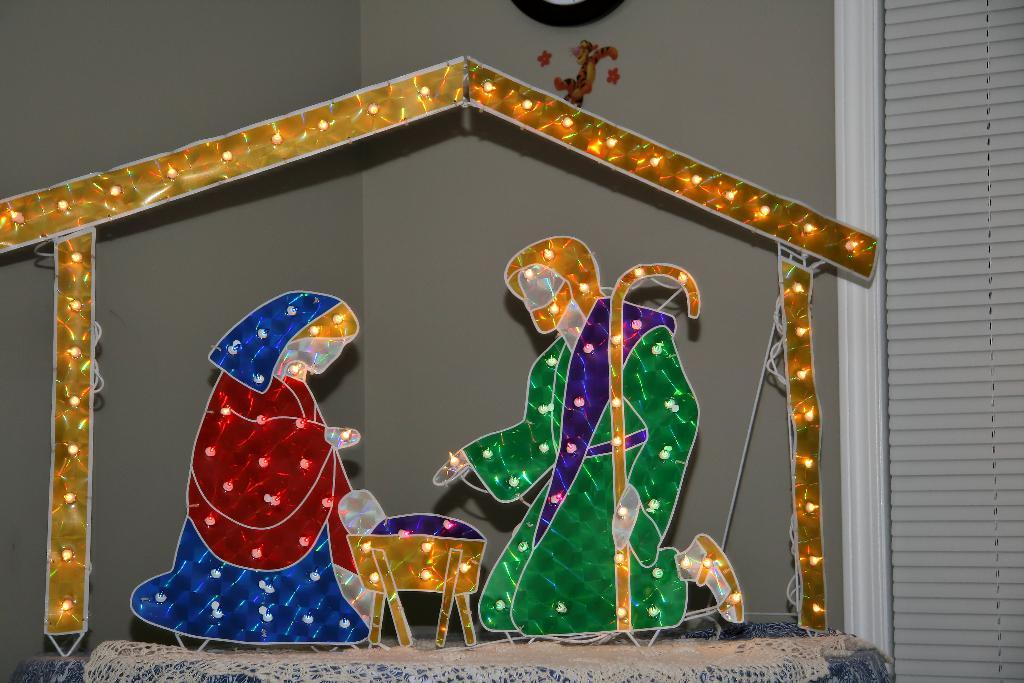What can be seen on the surface in the image? There is a decorative object on the surface in the image. What is located on the right side of the image? There is a window blind on the right side of the image. What is visible in the background of the image? There is a wall visible in the background of the image. What can be seen on the wall in the background of the image? There are objects on the wall in the background of the image. Can you tell me about the goldfish swimming in the image? There is no goldfish present in the image. What type of hobbies does the lawyer in the image have? There is no lawyer or mention of hobbies in the image. 